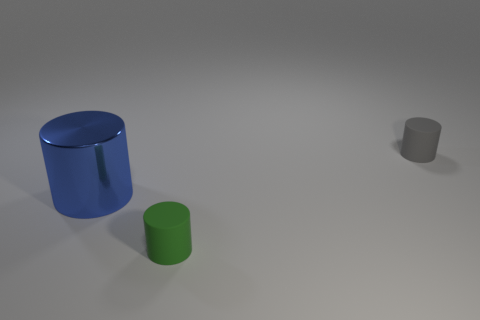Subtract all small gray cylinders. How many cylinders are left? 2 Add 3 big blue shiny cylinders. How many objects exist? 6 Subtract all yellow cylinders. Subtract all purple spheres. How many cylinders are left? 3 Subtract all green things. Subtract all gray things. How many objects are left? 1 Add 2 small rubber things. How many small rubber things are left? 4 Add 3 small brown spheres. How many small brown spheres exist? 3 Subtract 0 cyan cylinders. How many objects are left? 3 